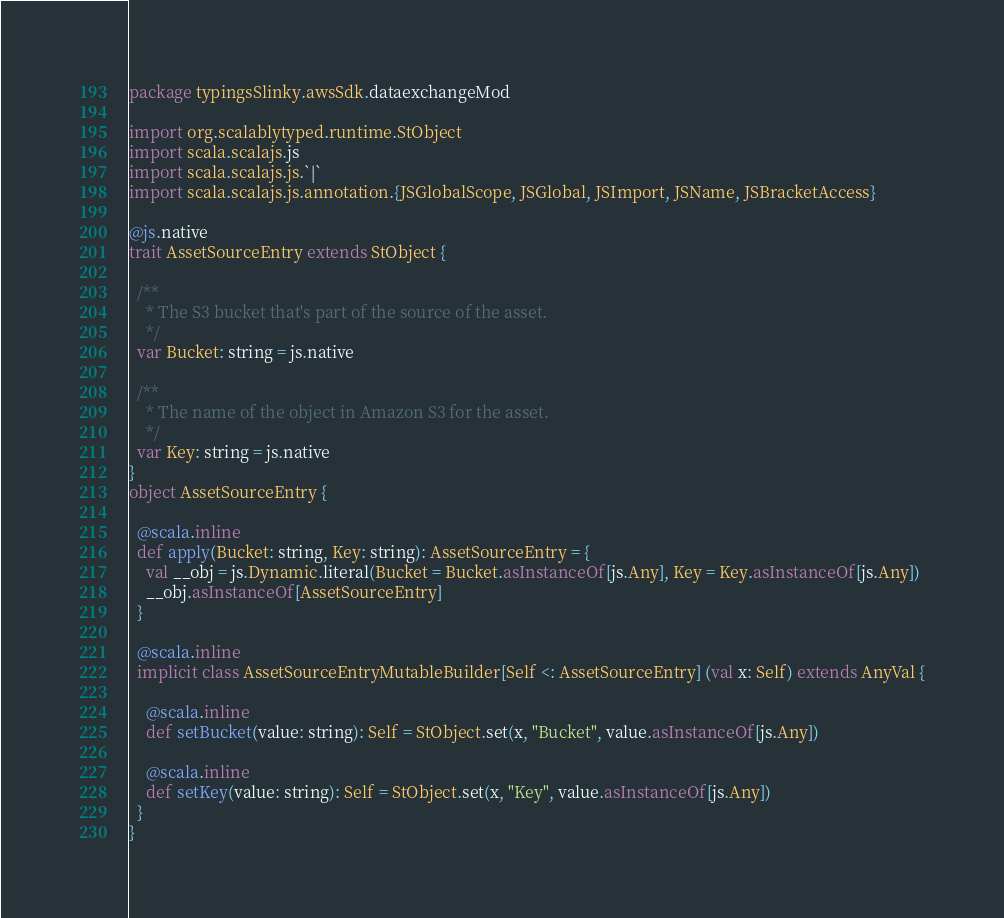Convert code to text. <code><loc_0><loc_0><loc_500><loc_500><_Scala_>package typingsSlinky.awsSdk.dataexchangeMod

import org.scalablytyped.runtime.StObject
import scala.scalajs.js
import scala.scalajs.js.`|`
import scala.scalajs.js.annotation.{JSGlobalScope, JSGlobal, JSImport, JSName, JSBracketAccess}

@js.native
trait AssetSourceEntry extends StObject {
  
  /**
    * The S3 bucket that's part of the source of the asset.
    */
  var Bucket: string = js.native
  
  /**
    * The name of the object in Amazon S3 for the asset.
    */
  var Key: string = js.native
}
object AssetSourceEntry {
  
  @scala.inline
  def apply(Bucket: string, Key: string): AssetSourceEntry = {
    val __obj = js.Dynamic.literal(Bucket = Bucket.asInstanceOf[js.Any], Key = Key.asInstanceOf[js.Any])
    __obj.asInstanceOf[AssetSourceEntry]
  }
  
  @scala.inline
  implicit class AssetSourceEntryMutableBuilder[Self <: AssetSourceEntry] (val x: Self) extends AnyVal {
    
    @scala.inline
    def setBucket(value: string): Self = StObject.set(x, "Bucket", value.asInstanceOf[js.Any])
    
    @scala.inline
    def setKey(value: string): Self = StObject.set(x, "Key", value.asInstanceOf[js.Any])
  }
}
</code> 